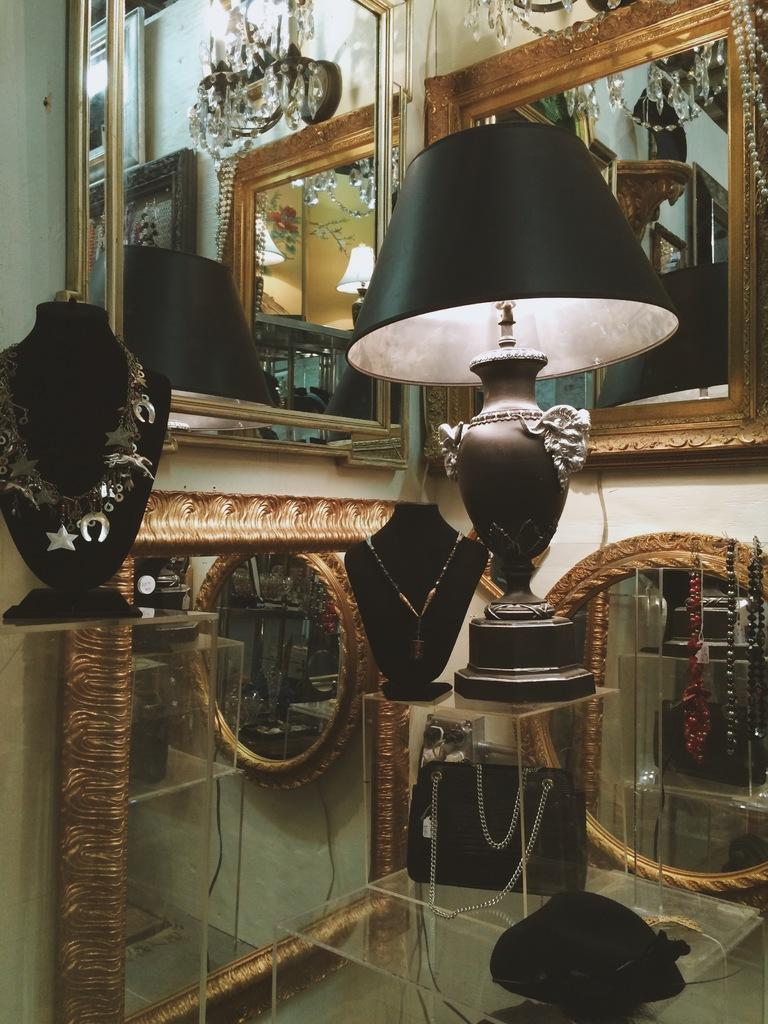What is present on the wall in the image? There are mirrors on the wall in the image. What type of lighting is visible in the image? There is a lamp in the image. What type of jewelry can be seen in the image? There are necklaces in the image. What is the table made of in the image? There is a glass table in the image. What is placed on the glass table in the image? There are objects on the glass table in the image. Can you see any farm animals in the image? There are no farm animals present in the image. How do the objects on the glass table move in the image? The objects on the glass table do not move in the image; they are stationary. 